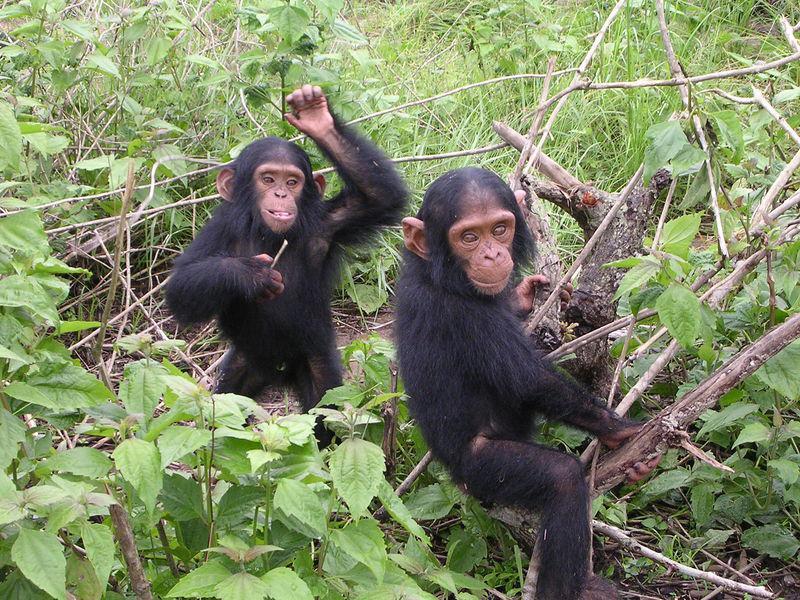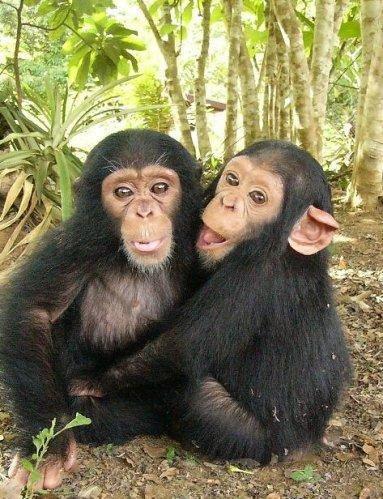The first image is the image on the left, the second image is the image on the right. Given the left and right images, does the statement "The right image contains exactly one chimpanzee." hold true? Answer yes or no. No. The first image is the image on the left, the second image is the image on the right. Assess this claim about the two images: "There is a single chimp outdoors in each of the images.". Correct or not? Answer yes or no. No. 